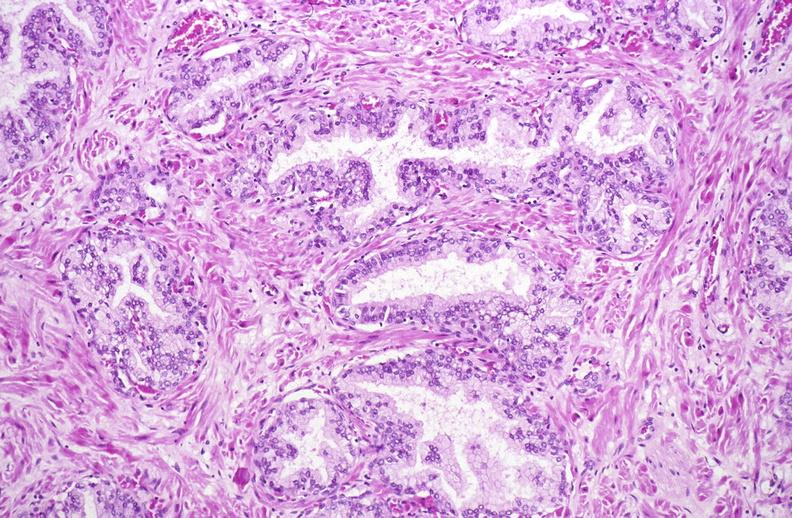does this image show normal prostate?
Answer the question using a single word or phrase. Yes 